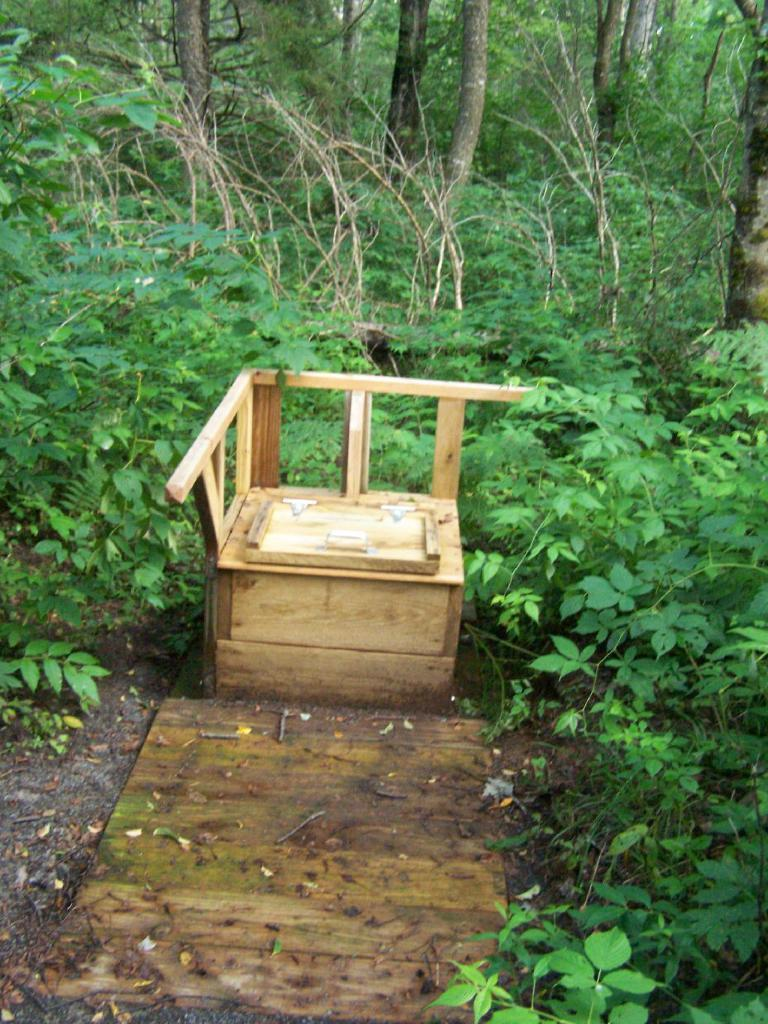What type of objects can be seen in the image? There are wooden objects in the image. What else is present in the image besides wooden objects? There are plants and dry leaves on the ground in the image. What can be seen in the background of the image? There are trees in the background of the image. What color of paint is being used on the fear in the image? There is no fear or paint present in the image. What type of cable can be seen connecting the wooden objects in the image? There is no cable connecting the wooden objects in the image. 